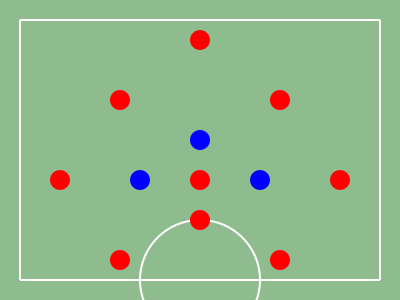Based on the player positions shown in the soccer field diagram, what formation is being depicted? To identify the formation, we need to analyze the positioning of the players from back to front:

1. Goalkeeper: There is one player (red) positioned at the bottom center of the field.

2. Defenders: There are three players (red) positioned in a line across the back of the field.

3. Midfielders: There are four players in the middle of the field:
   - Three players (red) are positioned in a line across the middle.
   - One player (blue) is slightly ahead of the other three, forming a diamond shape.

4. Forwards: There are three players at the top of the formation:
   - Two players (blue) are positioned wider and slightly behind the front player.
   - One player (red) is at the very top of the formation.

This arrangement of players (1-3-4-3) with a diamond midfield is characteristic of the 3-4-3 formation in soccer. The three defenders provide a solid backline, the four midfielders offer both defensive support and attacking options, while the three forwards create a potent attacking force.
Answer: 3-4-3 formation 